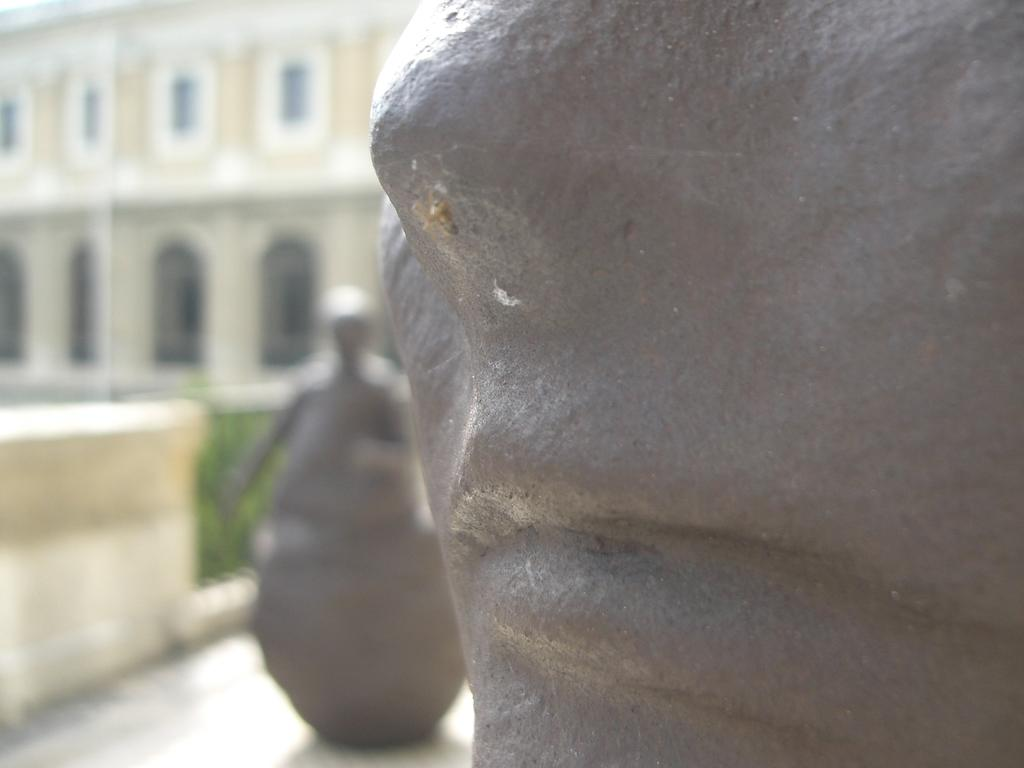What type of objects can be seen in the image? There are statues in the image. What is the color of the statues? The statues are gray in color. What can be seen in the background of the image? There are plants in the background of the image. What is the color of the plants? The plants are green in color. What is the color of the building in the image? The building in the image is cream and white in color. How does the statue control the shock of the incoming waves? There are no waves or shocks mentioned in the image, and the statues are not controlling anything. 